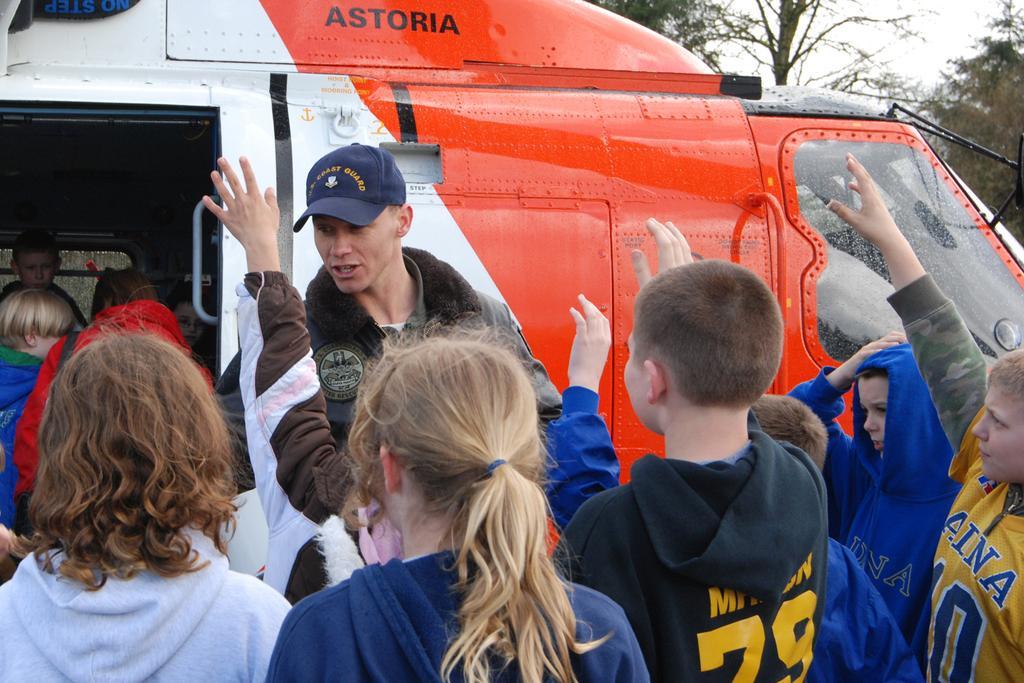How would you summarize this image in a sentence or two? In the center of the image we can see a person wearing a cap and a vehicle parked on the ground. To the left side of the image we can see some children inside the vehicle. In the foreground we can see a group of children standing on the ground. In the background, we can see some trees and the sky. 